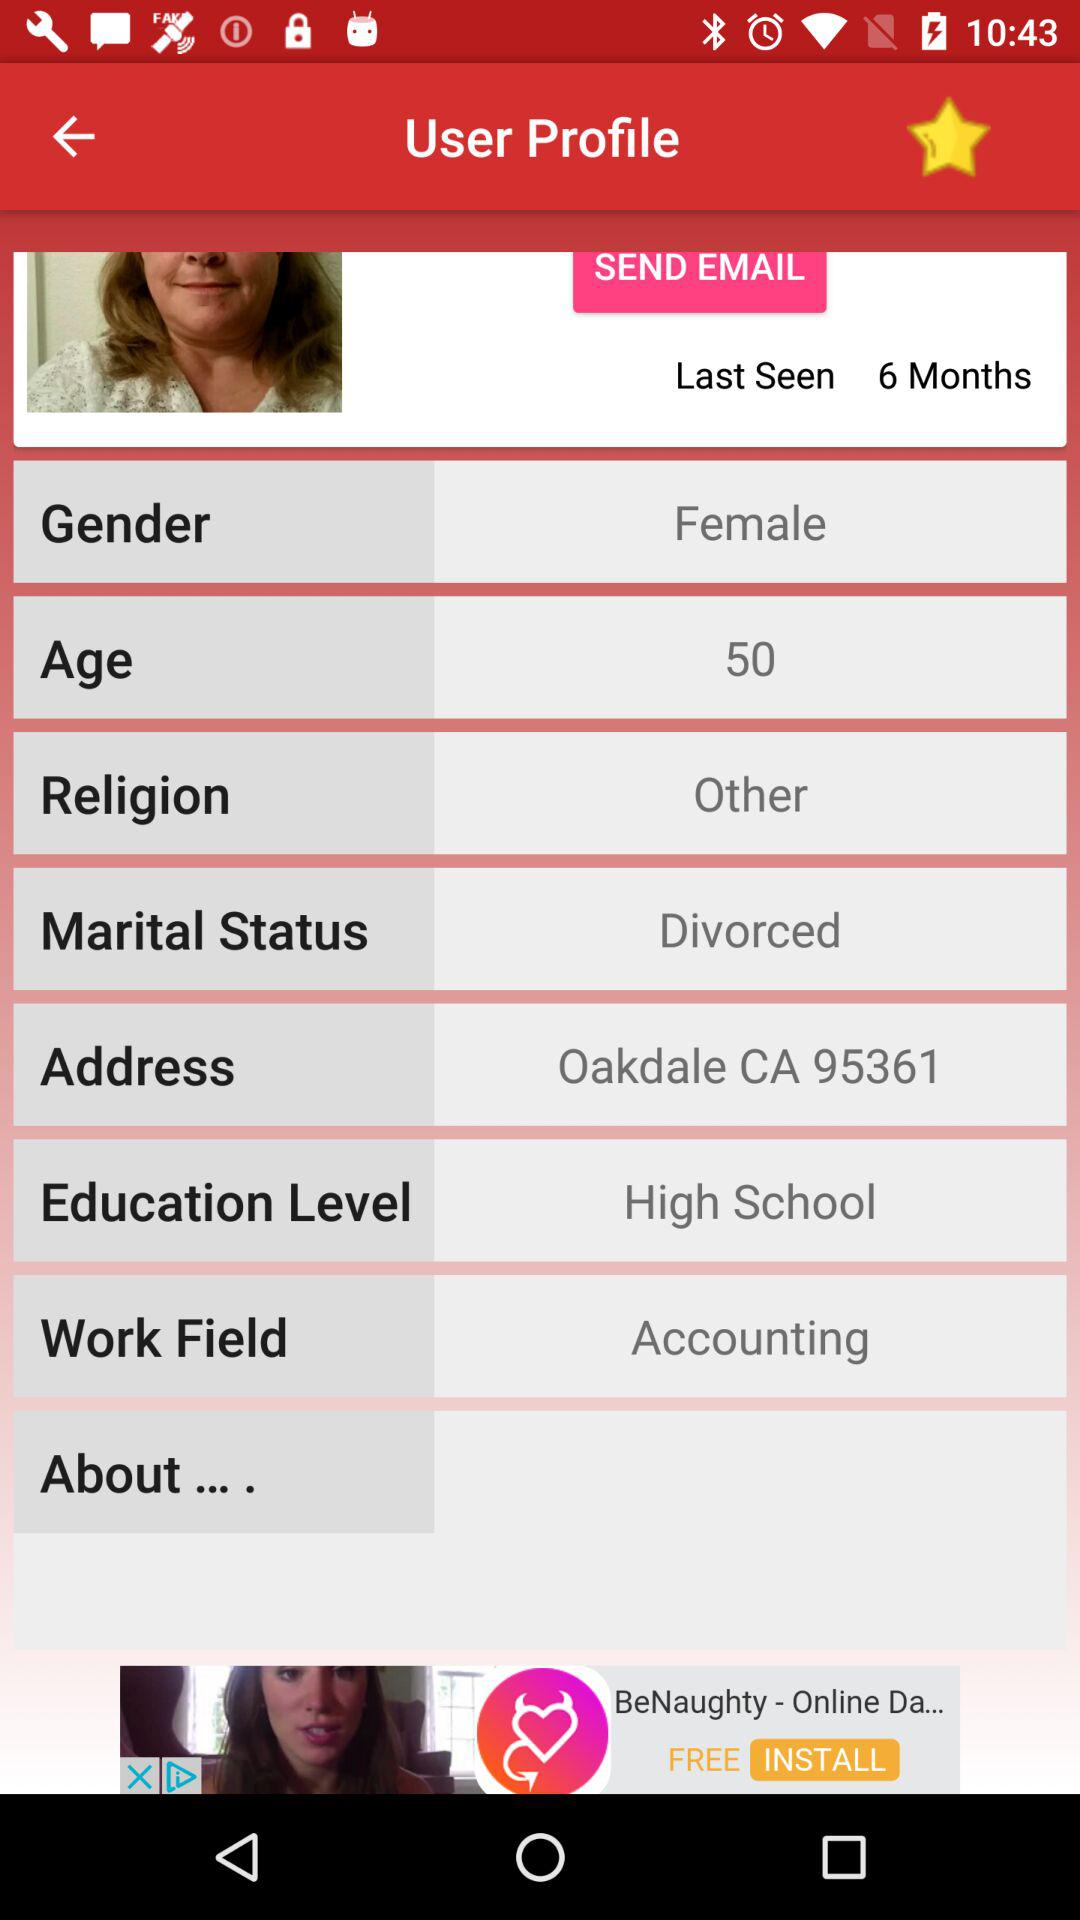When was the last time I saw this profile? The last time you saw this profile was 6 months ago. 